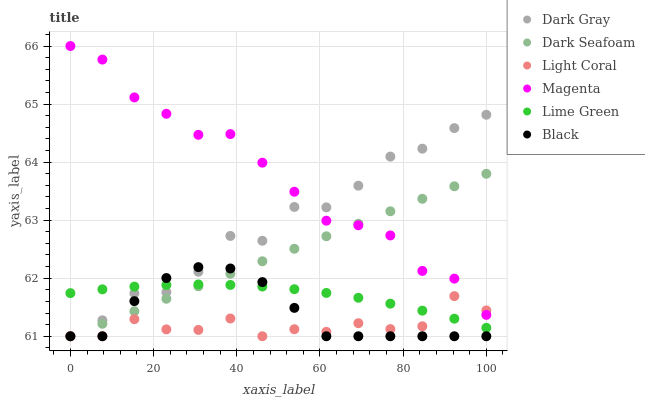Does Light Coral have the minimum area under the curve?
Answer yes or no. Yes. Does Magenta have the maximum area under the curve?
Answer yes or no. Yes. Does Dark Gray have the minimum area under the curve?
Answer yes or no. No. Does Dark Gray have the maximum area under the curve?
Answer yes or no. No. Is Dark Seafoam the smoothest?
Answer yes or no. Yes. Is Dark Gray the roughest?
Answer yes or no. Yes. Is Dark Gray the smoothest?
Answer yes or no. No. Is Dark Seafoam the roughest?
Answer yes or no. No. Does Light Coral have the lowest value?
Answer yes or no. Yes. Does Magenta have the lowest value?
Answer yes or no. No. Does Magenta have the highest value?
Answer yes or no. Yes. Does Dark Gray have the highest value?
Answer yes or no. No. Is Black less than Magenta?
Answer yes or no. Yes. Is Magenta greater than Black?
Answer yes or no. Yes. Does Lime Green intersect Light Coral?
Answer yes or no. Yes. Is Lime Green less than Light Coral?
Answer yes or no. No. Is Lime Green greater than Light Coral?
Answer yes or no. No. Does Black intersect Magenta?
Answer yes or no. No. 